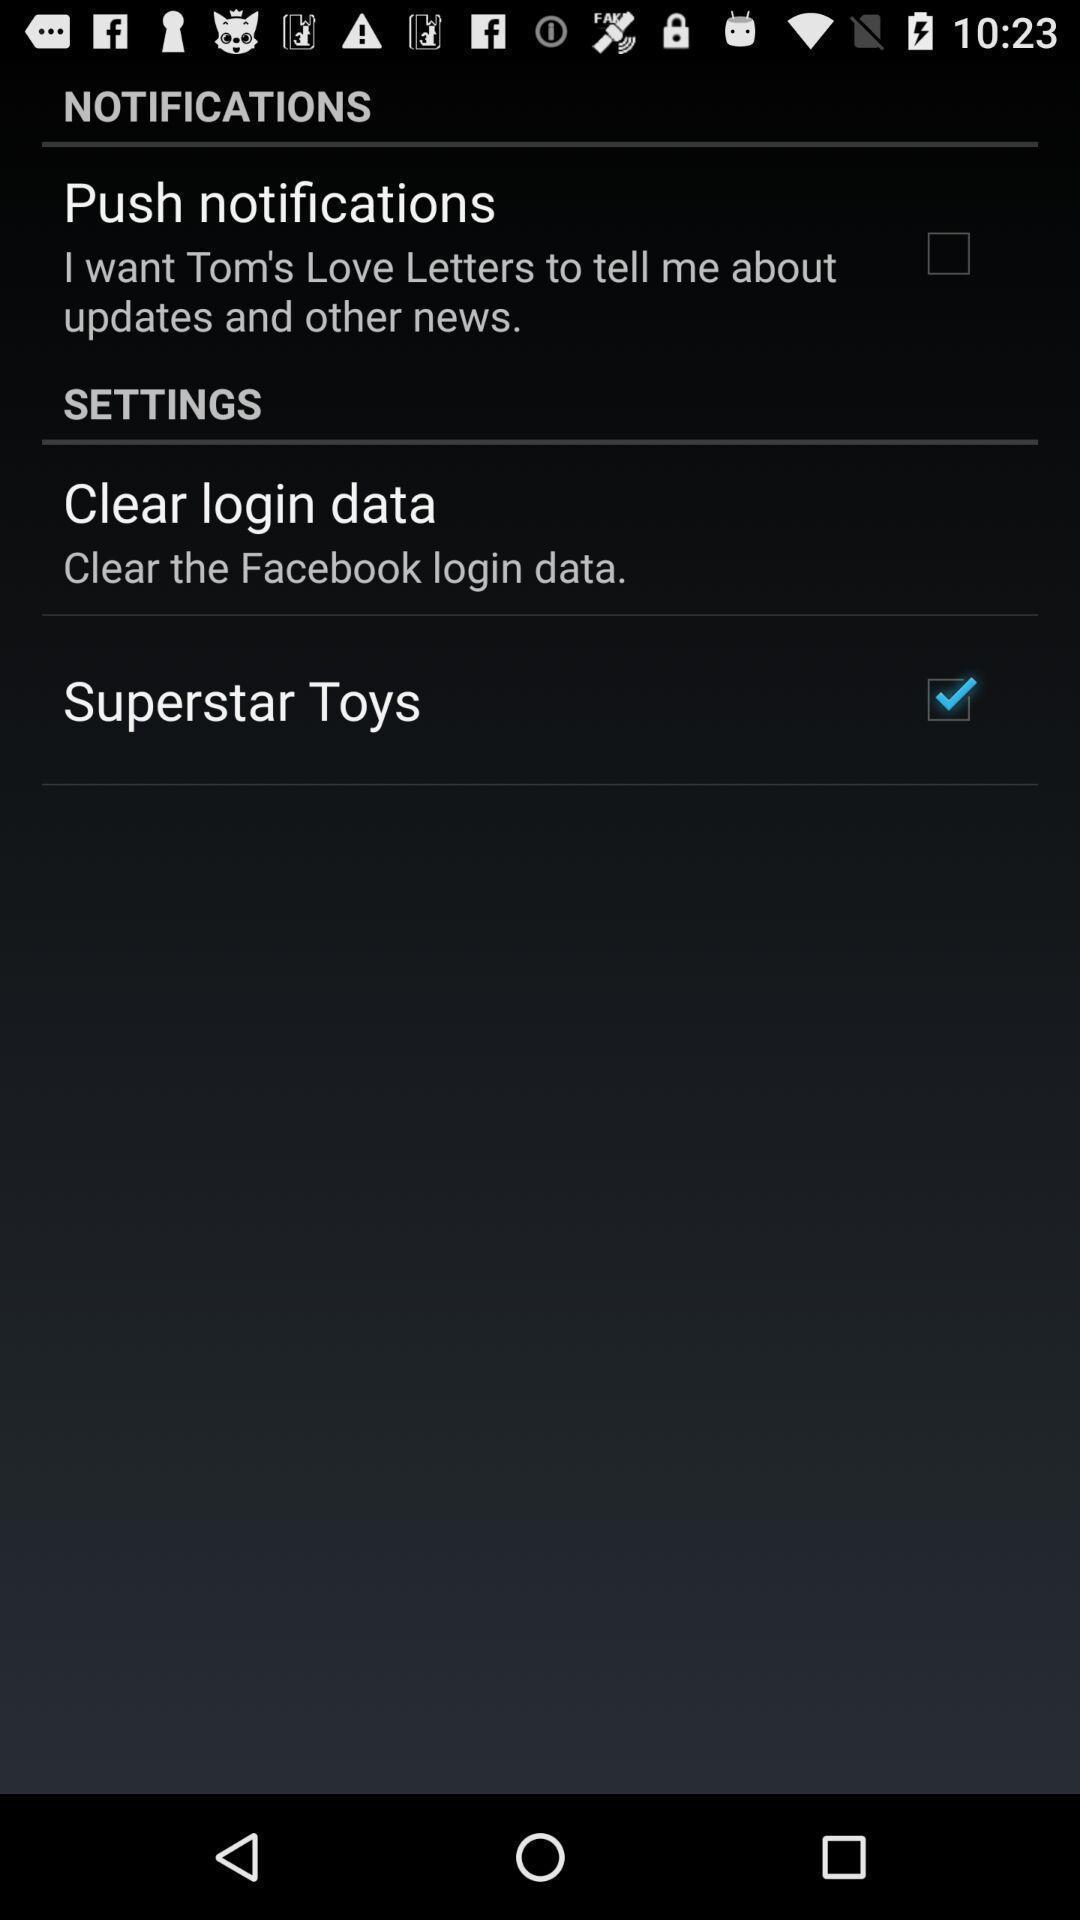What details can you identify in this image? Settings page of a social app. 